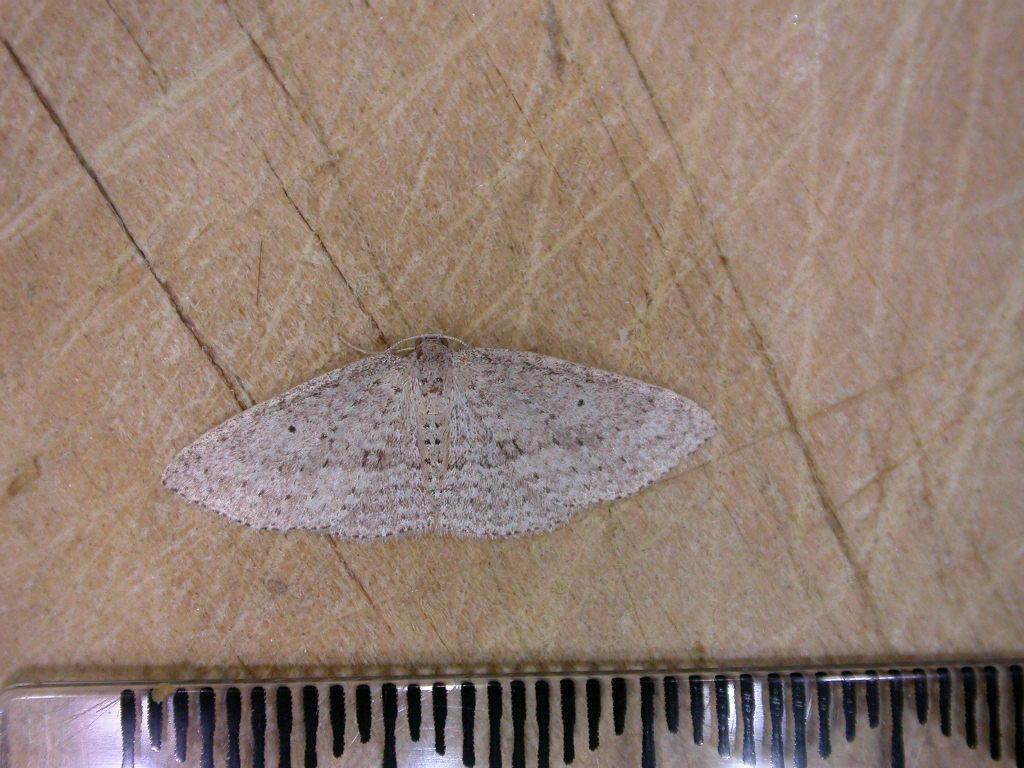What type of insect is in the image? There is a butterfly in the image. What colors can be seen on the butterfly? The butterfly has white and brown colors. What is the butterfly resting on in the image? The butterfly is on a wooden board. What can be seen at the bottom of the image? There is an object with a different color at the bottom of the image. How many women are present in the image? There are no women present in the image; it features a butterfly on a wooden board. What type of wilderness can be seen in the image? There is no wilderness present in the image; it features a butterfly on a wooden board. 